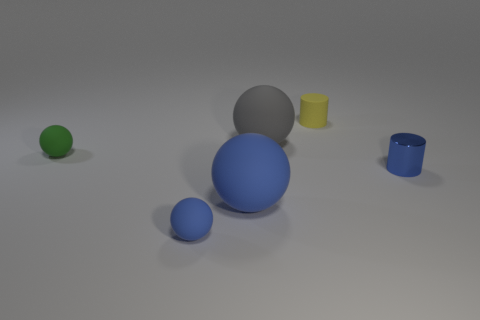Is there any other thing that is the same material as the blue cylinder?
Your answer should be compact. No. What size is the sphere that is right of the big matte sphere that is left of the gray rubber thing?
Offer a very short reply. Large. How big is the blue sphere that is to the right of the tiny blue object on the left side of the tiny object that is on the right side of the tiny yellow cylinder?
Your response must be concise. Large. There is a big matte thing in front of the tiny blue metal object; is its shape the same as the small blue thing on the right side of the gray object?
Make the answer very short. No. What number of other things are there of the same color as the small metallic cylinder?
Offer a very short reply. 2. There is a cylinder behind the blue cylinder; is it the same size as the green thing?
Offer a very short reply. Yes. Do the big thing behind the blue metal cylinder and the tiny cylinder behind the large gray thing have the same material?
Ensure brevity in your answer.  Yes. Are there any blue rubber things that have the same size as the gray rubber object?
Make the answer very short. Yes. What shape is the blue rubber object behind the tiny rubber sphere that is in front of the cylinder in front of the small yellow thing?
Offer a terse response. Sphere. Are there more tiny rubber spheres to the right of the green rubber thing than big yellow rubber cubes?
Ensure brevity in your answer.  Yes. 